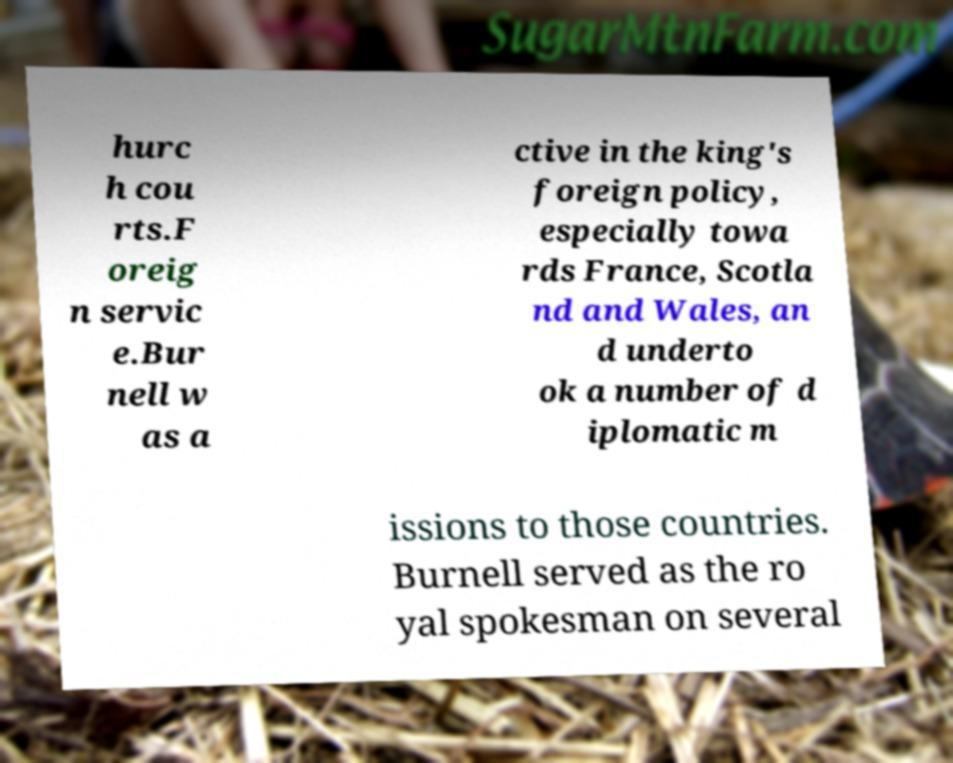Please identify and transcribe the text found in this image. hurc h cou rts.F oreig n servic e.Bur nell w as a ctive in the king's foreign policy, especially towa rds France, Scotla nd and Wales, an d underto ok a number of d iplomatic m issions to those countries. Burnell served as the ro yal spokesman on several 